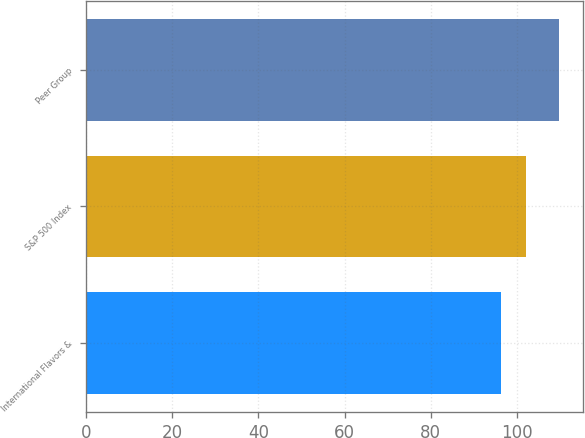Convert chart to OTSL. <chart><loc_0><loc_0><loc_500><loc_500><bar_chart><fcel>International Flavors &<fcel>S&P 500 Index<fcel>Peer Group<nl><fcel>96.19<fcel>102.11<fcel>109.69<nl></chart> 